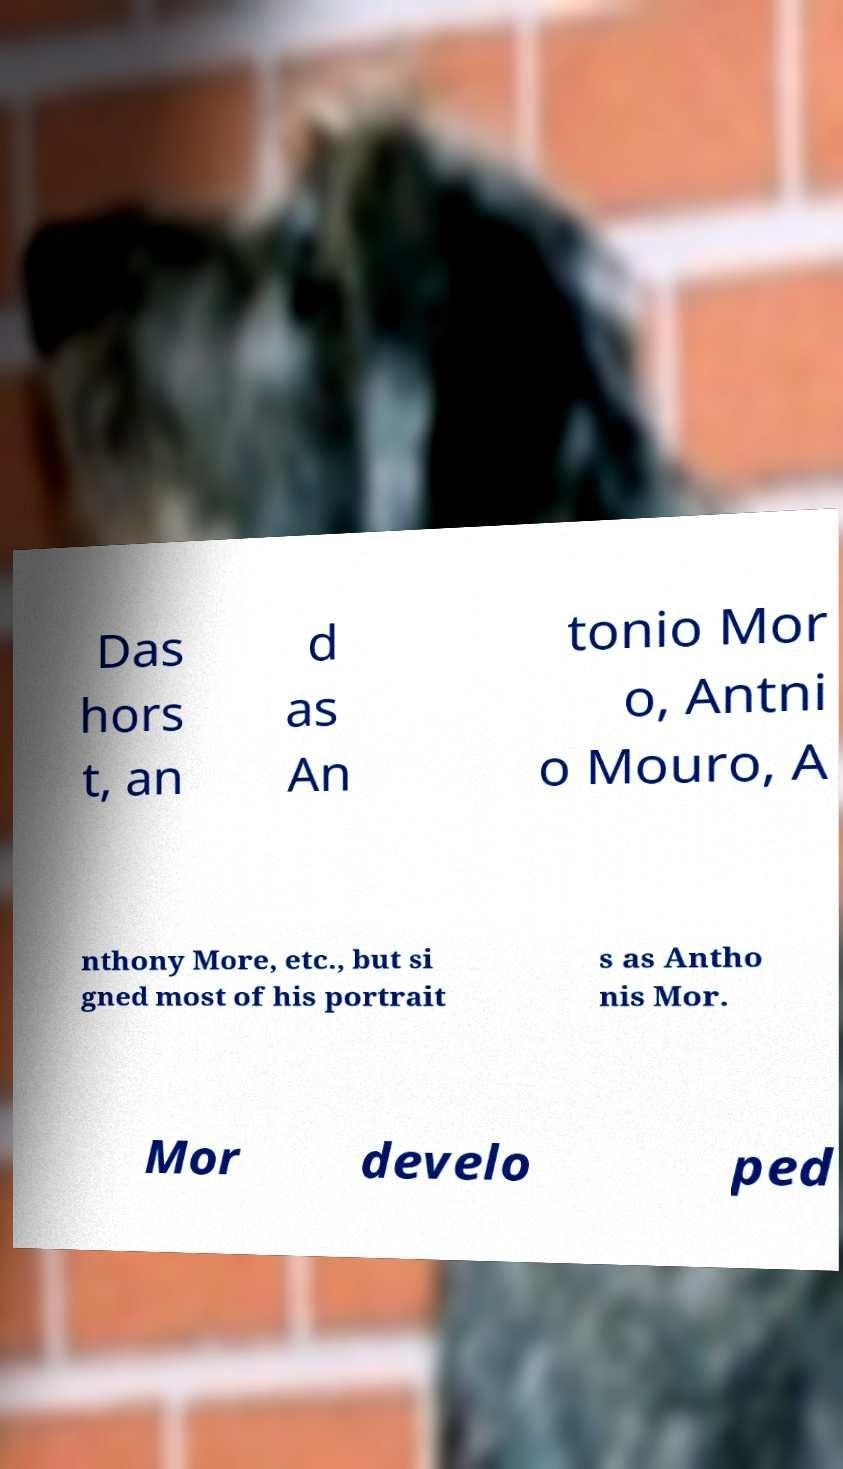Could you assist in decoding the text presented in this image and type it out clearly? Das hors t, an d as An tonio Mor o, Antni o Mouro, A nthony More, etc., but si gned most of his portrait s as Antho nis Mor. Mor develo ped 